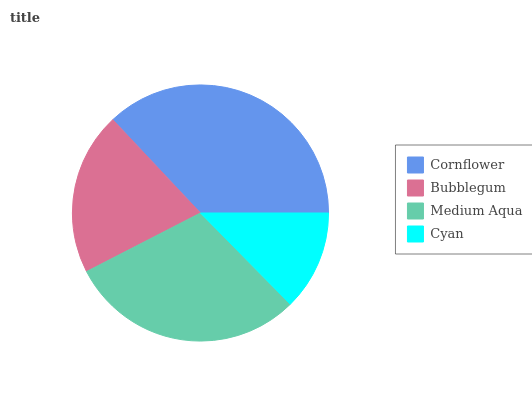Is Cyan the minimum?
Answer yes or no. Yes. Is Cornflower the maximum?
Answer yes or no. Yes. Is Bubblegum the minimum?
Answer yes or no. No. Is Bubblegum the maximum?
Answer yes or no. No. Is Cornflower greater than Bubblegum?
Answer yes or no. Yes. Is Bubblegum less than Cornflower?
Answer yes or no. Yes. Is Bubblegum greater than Cornflower?
Answer yes or no. No. Is Cornflower less than Bubblegum?
Answer yes or no. No. Is Medium Aqua the high median?
Answer yes or no. Yes. Is Bubblegum the low median?
Answer yes or no. Yes. Is Cyan the high median?
Answer yes or no. No. Is Medium Aqua the low median?
Answer yes or no. No. 